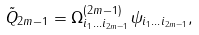<formula> <loc_0><loc_0><loc_500><loc_500>\tilde { Q } _ { 2 m - 1 } = \Omega _ { i _ { 1 } \dots i _ { 2 m - 1 } } ^ { ( 2 m - 1 ) } \psi _ { i _ { 1 } \dots i _ { 2 m - 1 } } ,</formula> 